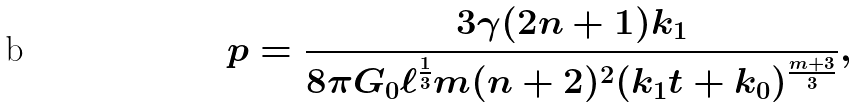Convert formula to latex. <formula><loc_0><loc_0><loc_500><loc_500>p = \frac { 3 \gamma ( 2 n + 1 ) k _ { 1 } } { 8 \pi G _ { 0 } \ell ^ { \frac { 1 } { 3 } } m ( n + 2 ) ^ { 2 } ( k _ { 1 } t + k _ { 0 } ) ^ { \frac { m + 3 } { 3 } } } ,</formula> 